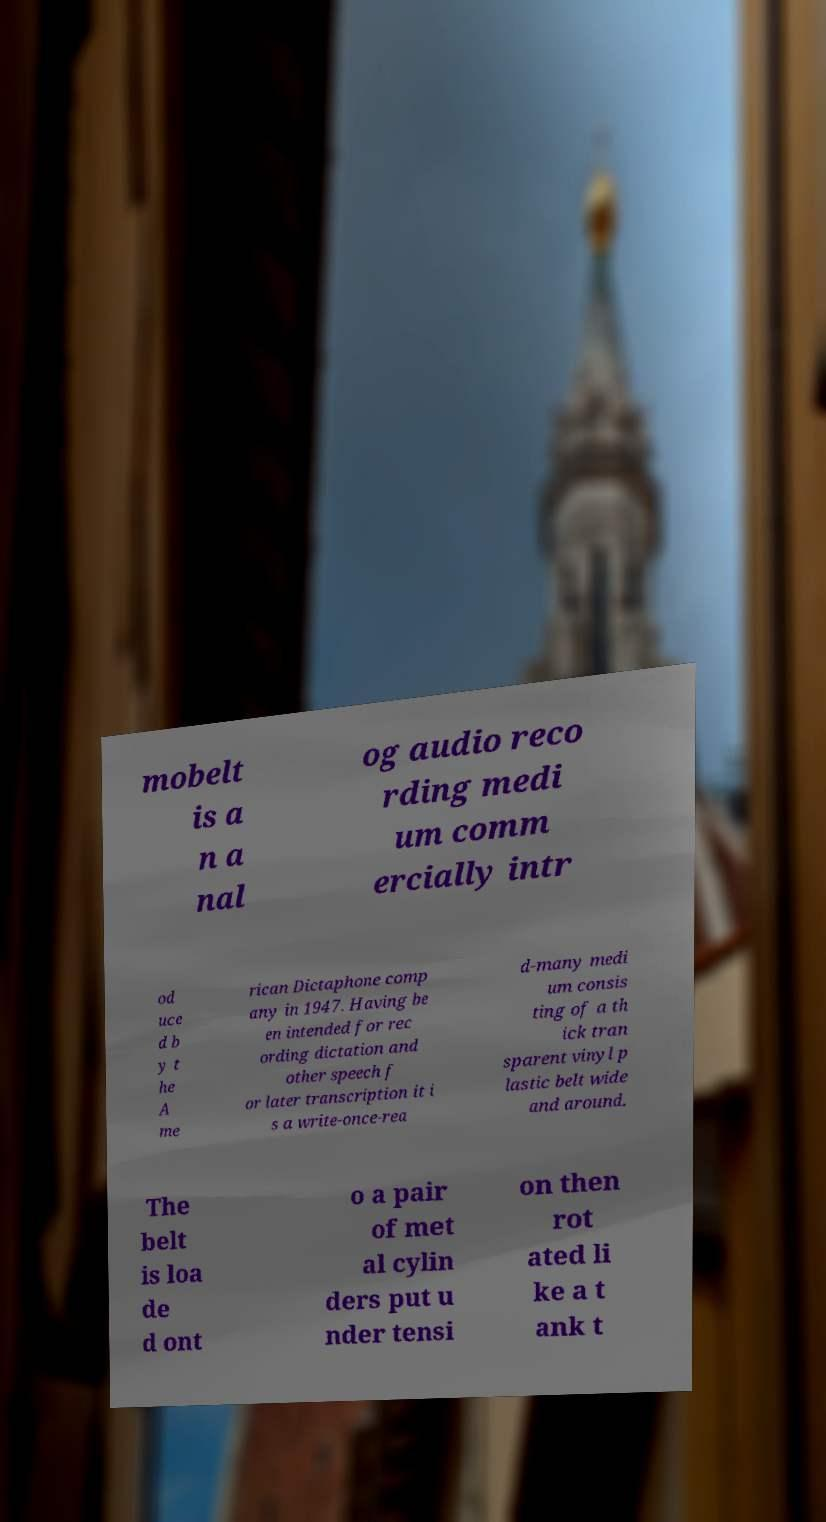Please read and relay the text visible in this image. What does it say? mobelt is a n a nal og audio reco rding medi um comm ercially intr od uce d b y t he A me rican Dictaphone comp any in 1947. Having be en intended for rec ording dictation and other speech f or later transcription it i s a write-once-rea d-many medi um consis ting of a th ick tran sparent vinyl p lastic belt wide and around. The belt is loa de d ont o a pair of met al cylin ders put u nder tensi on then rot ated li ke a t ank t 